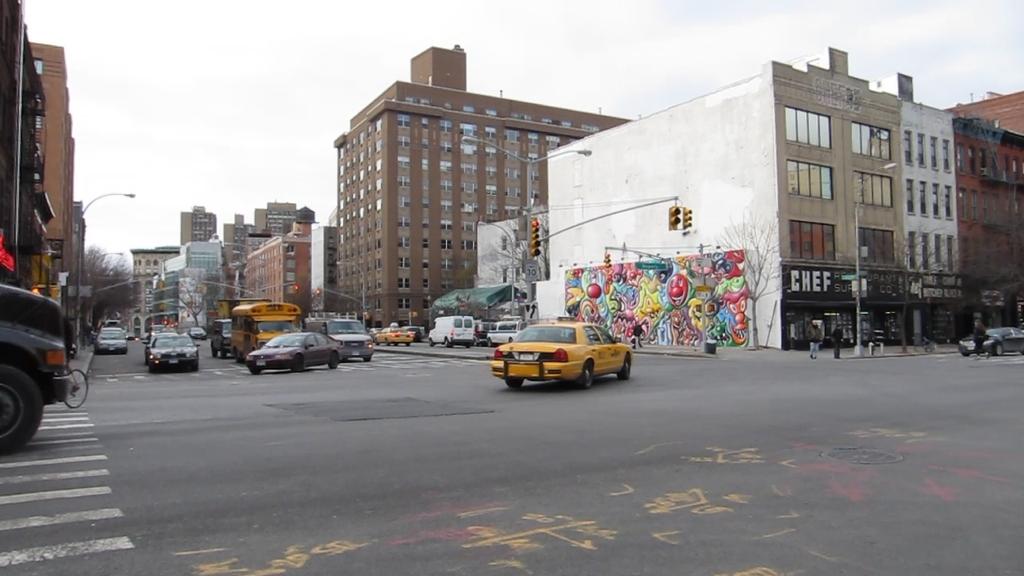What is the name on the building to the right of the graffiti?
Ensure brevity in your answer.  Chef. 